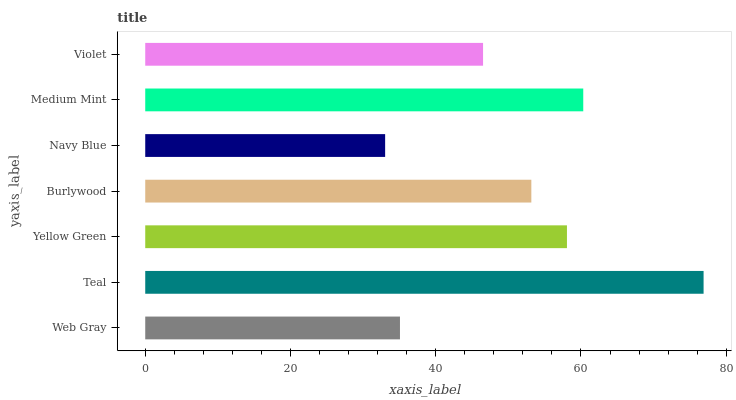Is Navy Blue the minimum?
Answer yes or no. Yes. Is Teal the maximum?
Answer yes or no. Yes. Is Yellow Green the minimum?
Answer yes or no. No. Is Yellow Green the maximum?
Answer yes or no. No. Is Teal greater than Yellow Green?
Answer yes or no. Yes. Is Yellow Green less than Teal?
Answer yes or no. Yes. Is Yellow Green greater than Teal?
Answer yes or no. No. Is Teal less than Yellow Green?
Answer yes or no. No. Is Burlywood the high median?
Answer yes or no. Yes. Is Burlywood the low median?
Answer yes or no. Yes. Is Web Gray the high median?
Answer yes or no. No. Is Medium Mint the low median?
Answer yes or no. No. 